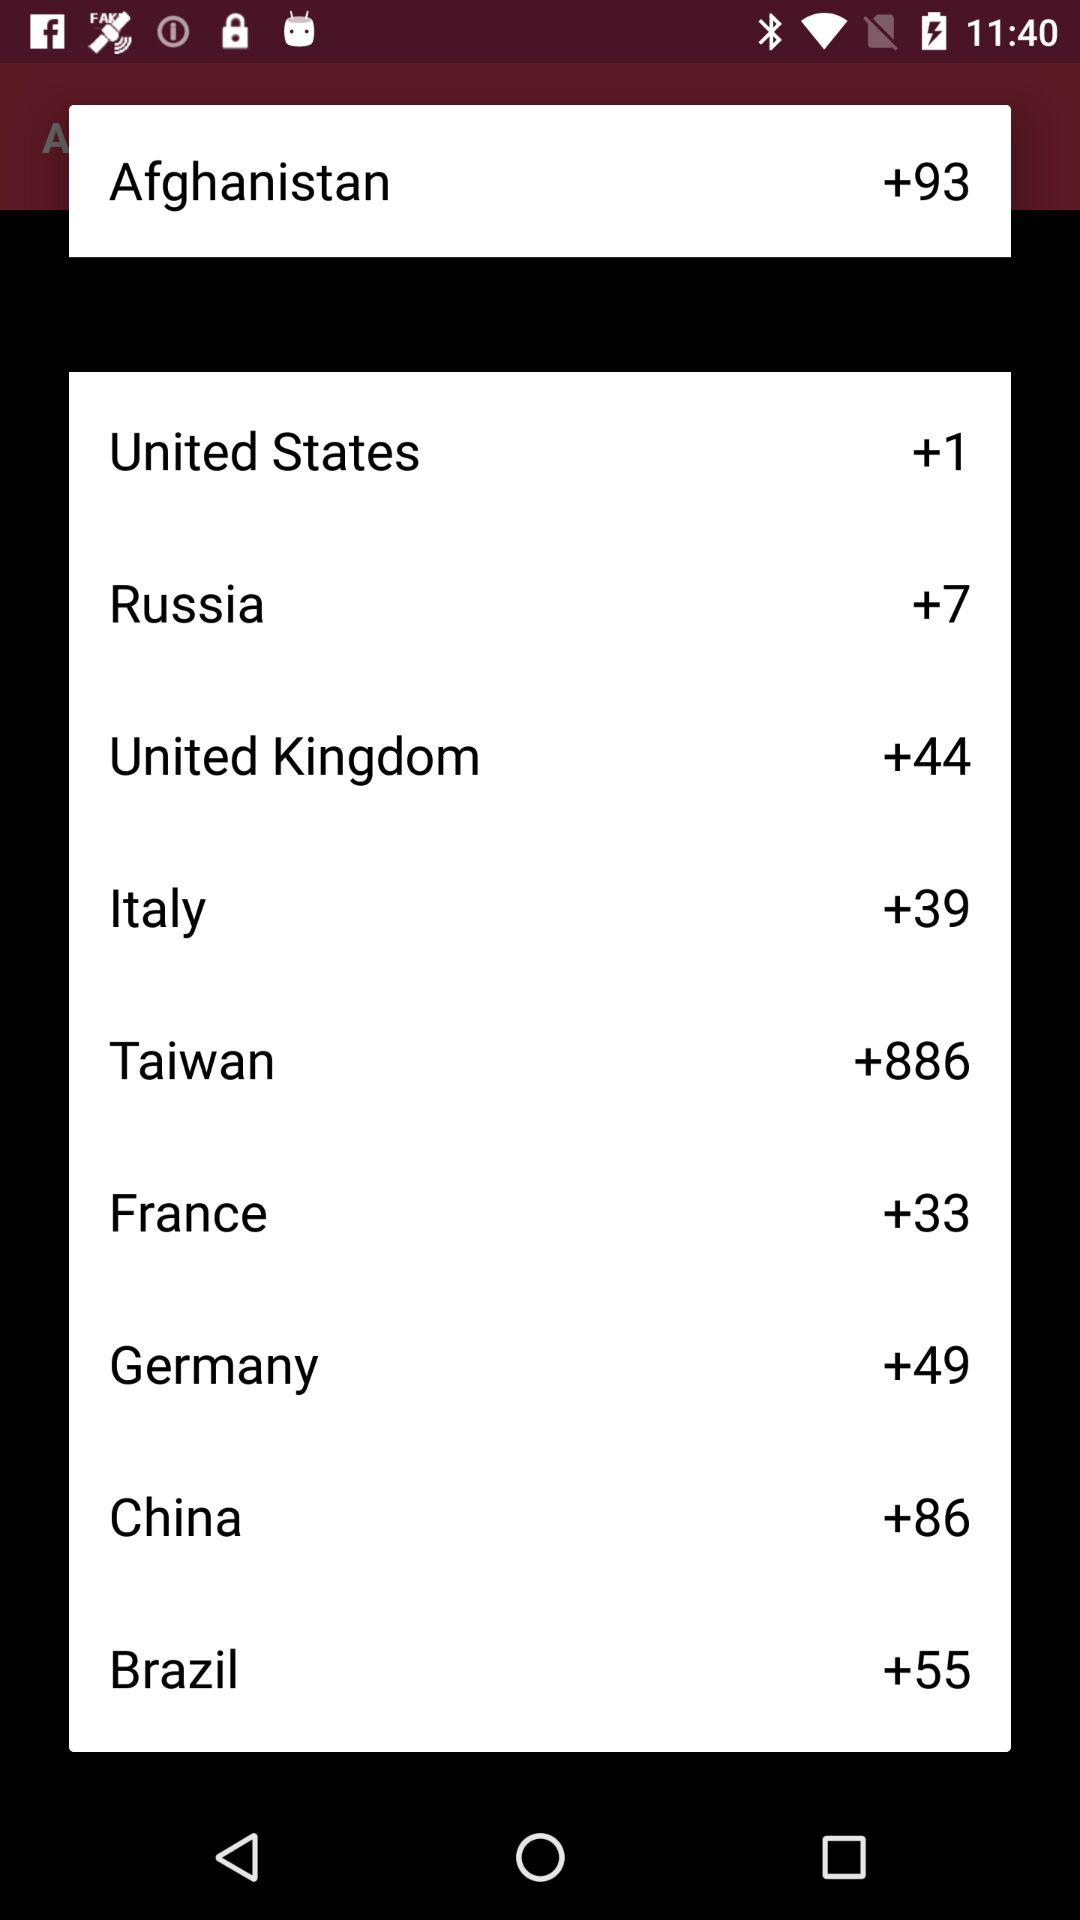What is the country code for the United States? The country code for the United States is +1. 